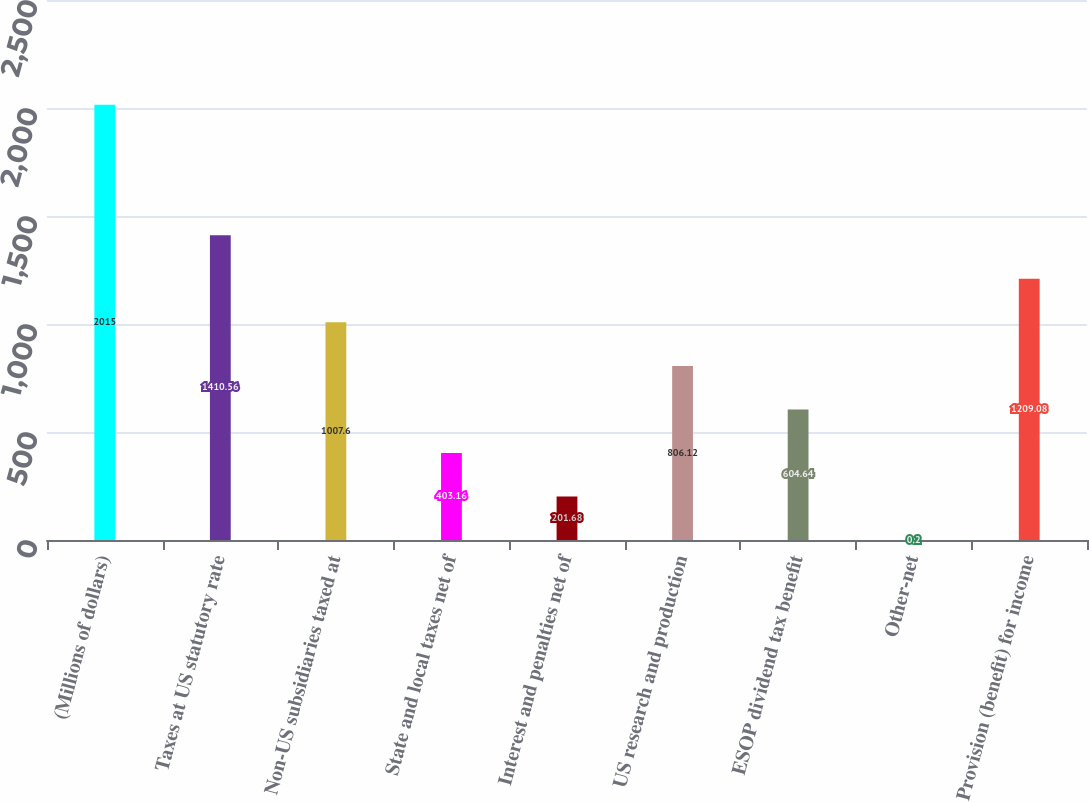Convert chart. <chart><loc_0><loc_0><loc_500><loc_500><bar_chart><fcel>(Millions of dollars)<fcel>Taxes at US statutory rate<fcel>Non-US subsidiaries taxed at<fcel>State and local taxes net of<fcel>Interest and penalties net of<fcel>US research and production<fcel>ESOP dividend tax benefit<fcel>Other-net<fcel>Provision (benefit) for income<nl><fcel>2015<fcel>1410.56<fcel>1007.6<fcel>403.16<fcel>201.68<fcel>806.12<fcel>604.64<fcel>0.2<fcel>1209.08<nl></chart> 